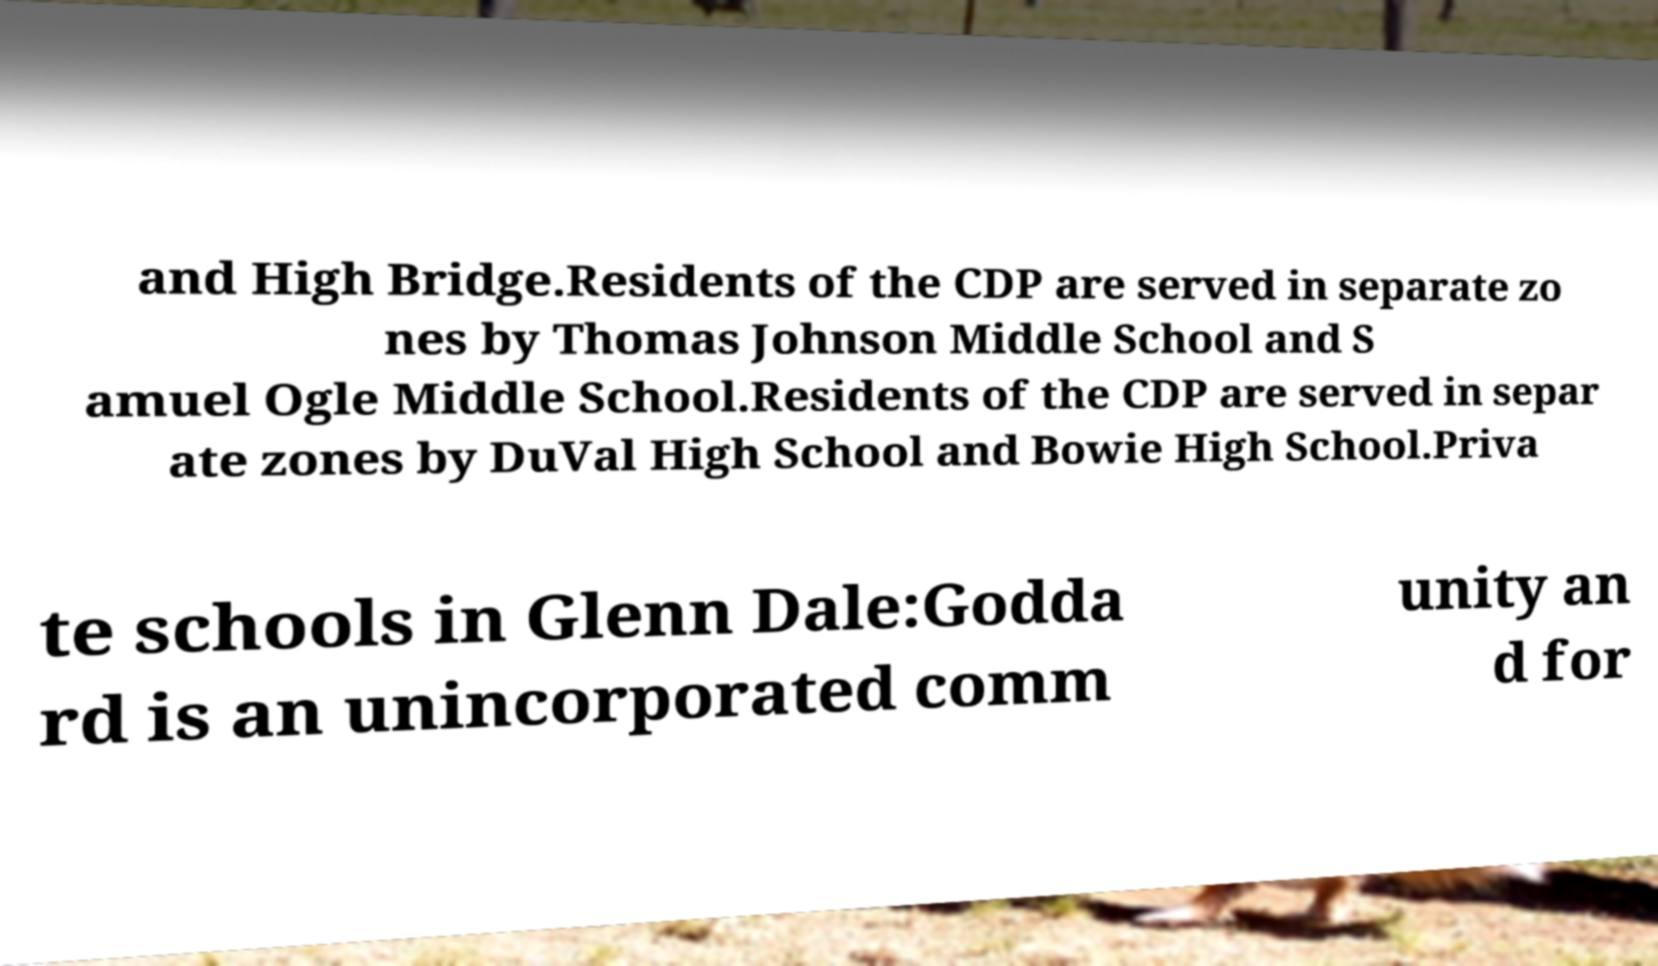There's text embedded in this image that I need extracted. Can you transcribe it verbatim? and High Bridge.Residents of the CDP are served in separate zo nes by Thomas Johnson Middle School and S amuel Ogle Middle School.Residents of the CDP are served in separ ate zones by DuVal High School and Bowie High School.Priva te schools in Glenn Dale:Godda rd is an unincorporated comm unity an d for 